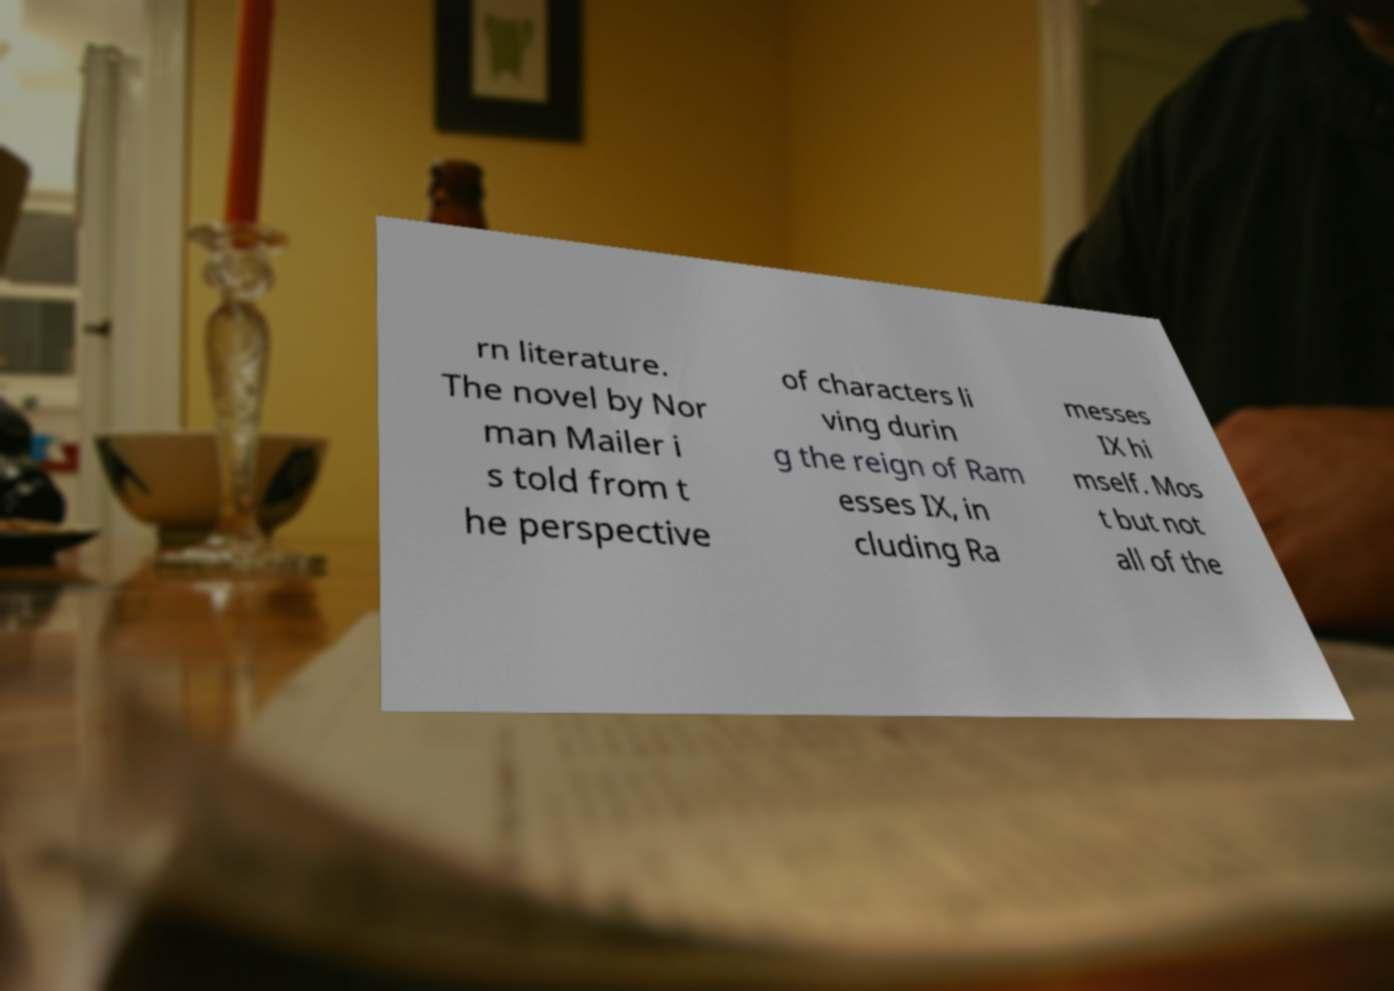Can you read and provide the text displayed in the image?This photo seems to have some interesting text. Can you extract and type it out for me? rn literature. The novel by Nor man Mailer i s told from t he perspective of characters li ving durin g the reign of Ram esses IX, in cluding Ra messes IX hi mself. Mos t but not all of the 